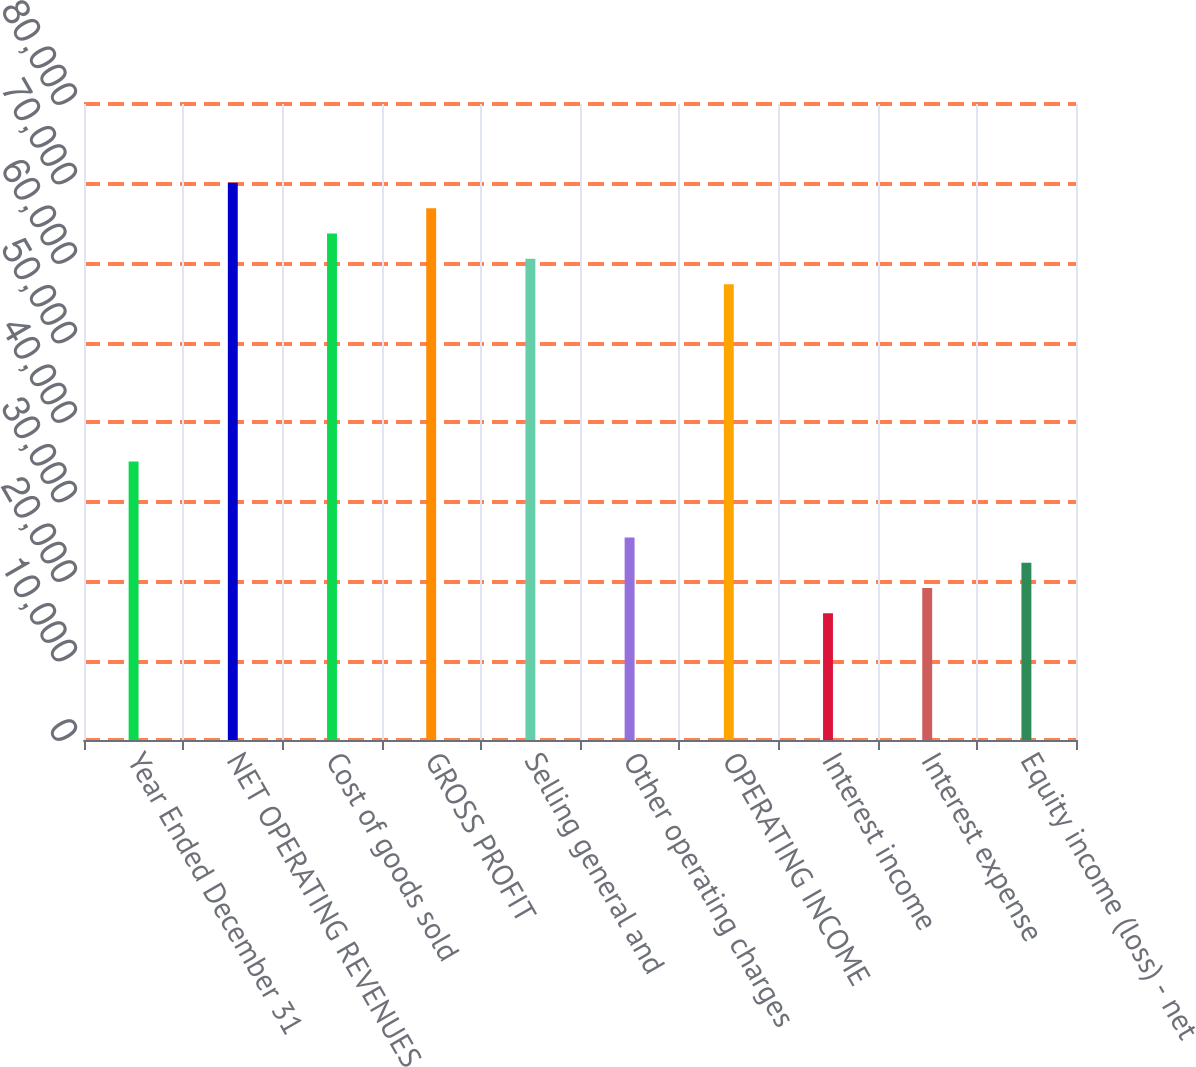Convert chart to OTSL. <chart><loc_0><loc_0><loc_500><loc_500><bar_chart><fcel>Year Ended December 31<fcel>NET OPERATING REVENUES<fcel>Cost of goods sold<fcel>GROSS PROFIT<fcel>Selling general and<fcel>Other operating charges<fcel>OPERATING INCOME<fcel>Interest income<fcel>Interest expense<fcel>Equity income (loss) - net<nl><fcel>35041.4<fcel>70081.4<fcel>63710.5<fcel>66895.9<fcel>60525.1<fcel>25485.1<fcel>57339.6<fcel>15928.8<fcel>19114.2<fcel>22299.7<nl></chart> 